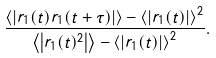Convert formula to latex. <formula><loc_0><loc_0><loc_500><loc_500>\frac { \left < \left | r _ { 1 } ( t ) r _ { 1 } ( t + \tau ) \right | \right > - \left < \left | r _ { 1 } ( t ) \right | \right > ^ { 2 } } { \left < \left | r _ { 1 } ( t ) ^ { 2 } \right | \right > - \left < \left | r _ { 1 } ( t ) \right | \right > ^ { 2 } } .</formula> 